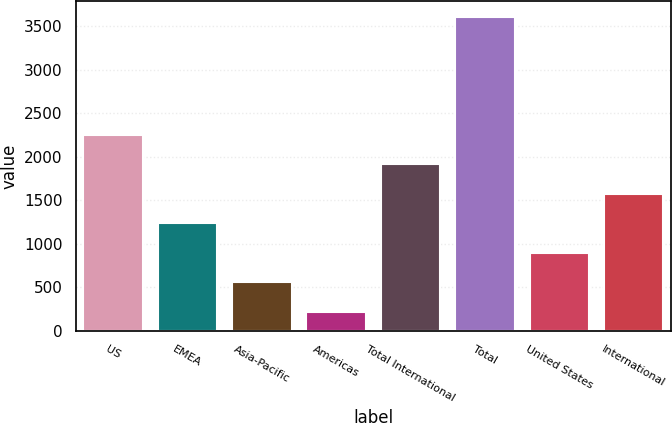Convert chart. <chart><loc_0><loc_0><loc_500><loc_500><bar_chart><fcel>US<fcel>EMEA<fcel>Asia-Pacific<fcel>Americas<fcel>Total International<fcel>Total<fcel>United States<fcel>International<nl><fcel>2250.96<fcel>1236.03<fcel>559.41<fcel>221.1<fcel>1912.65<fcel>3604.2<fcel>897.72<fcel>1574.34<nl></chart> 